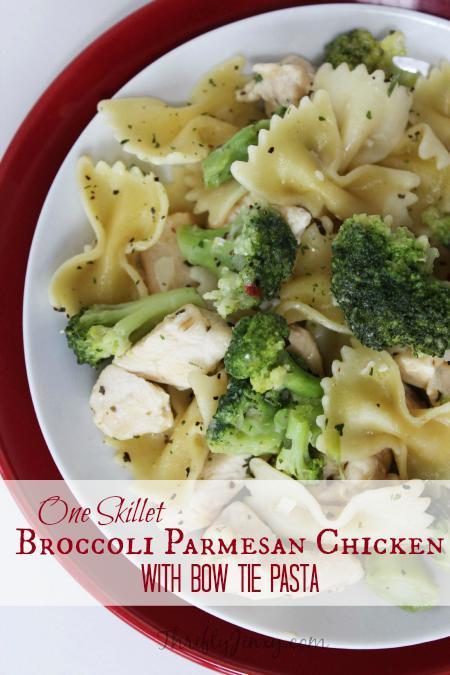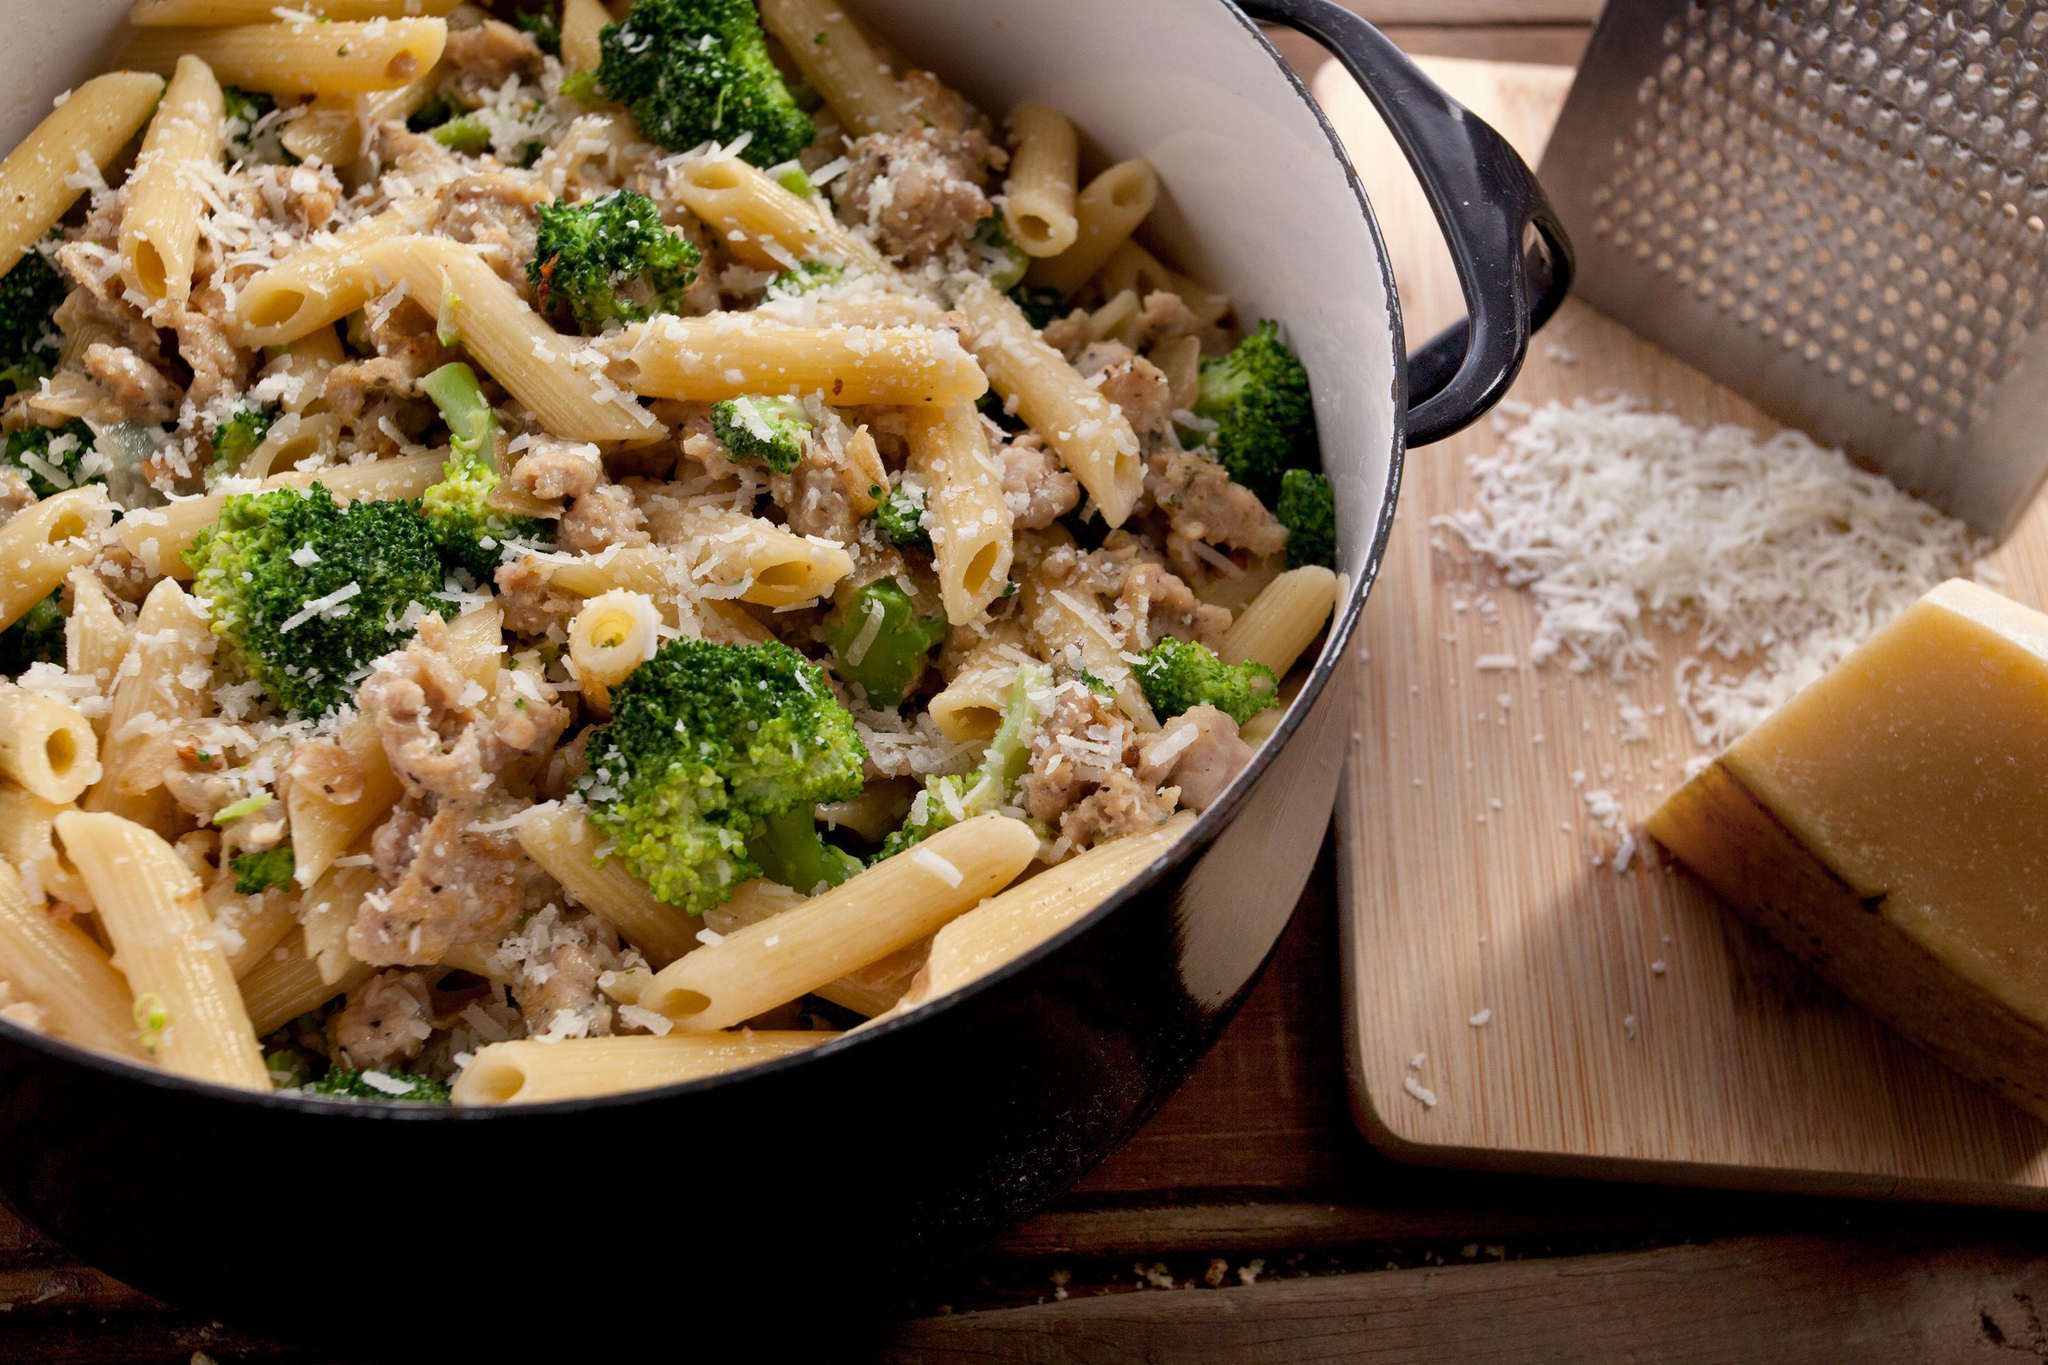The first image is the image on the left, the second image is the image on the right. Considering the images on both sides, is "An image shows a round bowl of broccoli and pasta with a silver serving spoon inserted in it." valid? Answer yes or no. No. 